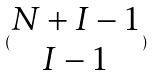Convert formula to latex. <formula><loc_0><loc_0><loc_500><loc_500>( \begin{matrix} N + I - 1 \\ I - 1 \end{matrix} )</formula> 